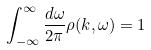<formula> <loc_0><loc_0><loc_500><loc_500>\int _ { - \infty } ^ { \infty } \frac { d \omega } { 2 \pi } \rho ( k , \omega ) = 1</formula> 